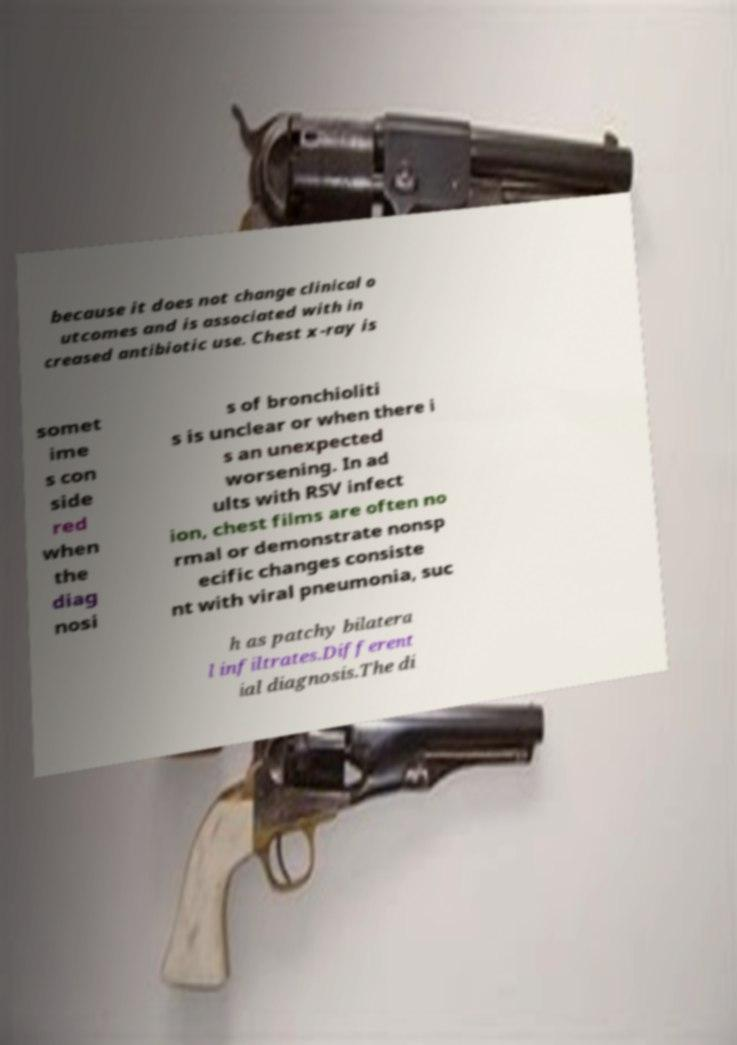Could you assist in decoding the text presented in this image and type it out clearly? because it does not change clinical o utcomes and is associated with in creased antibiotic use. Chest x-ray is somet ime s con side red when the diag nosi s of bronchioliti s is unclear or when there i s an unexpected worsening. In ad ults with RSV infect ion, chest films are often no rmal or demonstrate nonsp ecific changes consiste nt with viral pneumonia, suc h as patchy bilatera l infiltrates.Different ial diagnosis.The di 